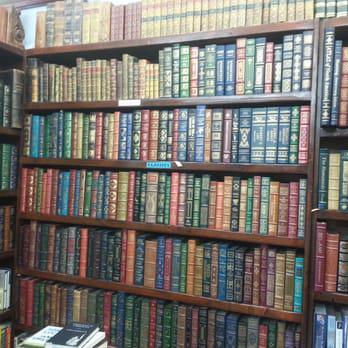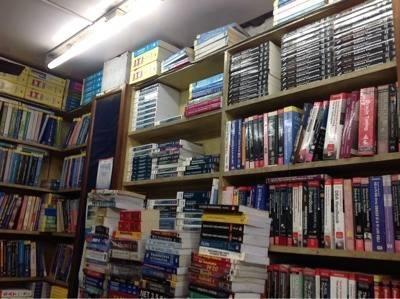The first image is the image on the left, the second image is the image on the right. Given the left and right images, does the statement "Both images are have a few bookshelves close up, and no people." hold true? Answer yes or no. Yes. 